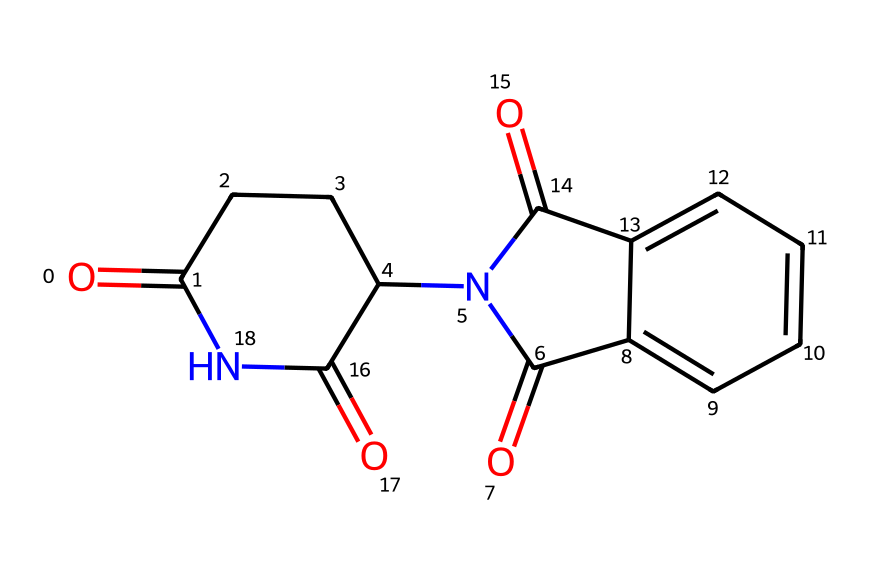What is the molecular formula of thalidomide? By analyzing the SMILES representation, we can identify the elements present. The carbon (C), hydrogen (H), nitrogen (N), and oxygen (O) atoms can be counted. The unique arrangement shows there are 13 carbons, 10 hydrogens, 2 nitrogens, and 4 oxygens. Thus, the molecular formula is C13H10N2O4.
Answer: C13H10N2O4 How many rings are present in the structure of thalidomide? The SMILES notation indicates cyclic structures through the use of numbers. The notation shows two numbered rings, suggesting there are two rings present in the thalidomide molecule.
Answer: 2 What functional groups are present in thalidomide? By examining the structure derived from the SMILES, we can identify functional groups. The presence of carbonyl (C=O) groups and amide (C(=O)N) groups are evident, indicating the molecule contains amide and carbonyl functional groups.
Answer: amide, carbonyl What is the primary toxicological concern associated with thalidomide? Thalidomide is primarily known for its teratogenic effects, which means it can cause malformations in developing embryos. This famous instance of its impact on embryonic development is linked to its use during pregnancy.
Answer: teratogenicity Describe the arrangement of nitrogen atoms in thalidomide. The SMILES shows two nitrogen atoms present in the structure, one within an amide group and one as part of the cyclic structure. Their specific arrangement contributes to the overall chemical properties and pharmacologic activity of thalidomide.
Answer: 2 nitrogen atoms Which aspect of thalidomide's structure contributes to its biological activity? The specific arrangement of the functional groups, including the carbonyl and amide groups and the stereochemistry of the molecule, is essential for its receptor interactions, impacting its biological activity.
Answer: functional group arrangement 